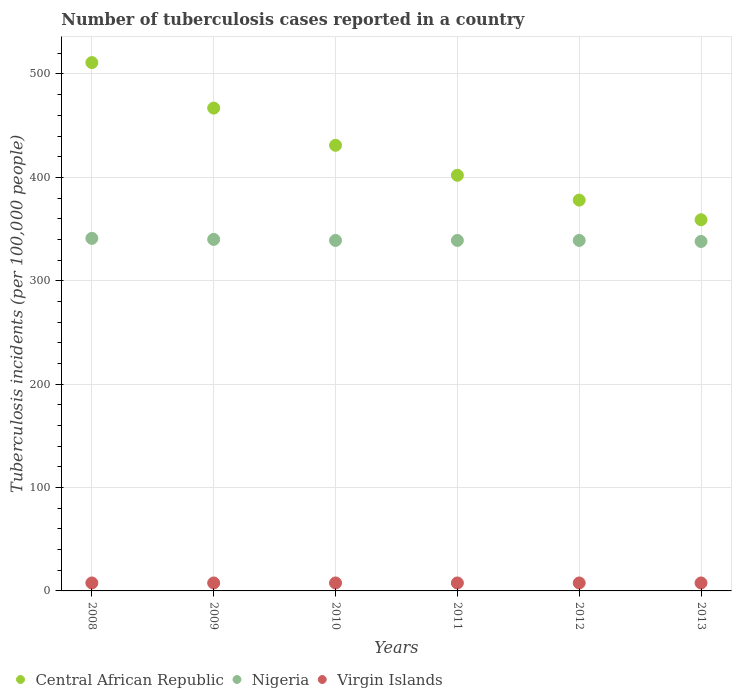Is the number of dotlines equal to the number of legend labels?
Keep it short and to the point. Yes. What is the number of tuberculosis cases reported in in Central African Republic in 2011?
Your response must be concise. 402. Across all years, what is the maximum number of tuberculosis cases reported in in Nigeria?
Your response must be concise. 341. Across all years, what is the minimum number of tuberculosis cases reported in in Nigeria?
Offer a terse response. 338. In which year was the number of tuberculosis cases reported in in Virgin Islands maximum?
Give a very brief answer. 2008. What is the total number of tuberculosis cases reported in in Nigeria in the graph?
Your answer should be compact. 2036. What is the difference between the number of tuberculosis cases reported in in Central African Republic in 2008 and that in 2010?
Ensure brevity in your answer.  80. What is the difference between the number of tuberculosis cases reported in in Virgin Islands in 2011 and the number of tuberculosis cases reported in in Nigeria in 2008?
Ensure brevity in your answer.  -333.3. What is the average number of tuberculosis cases reported in in Nigeria per year?
Keep it short and to the point. 339.33. In the year 2012, what is the difference between the number of tuberculosis cases reported in in Central African Republic and number of tuberculosis cases reported in in Virgin Islands?
Your answer should be compact. 370.3. In how many years, is the number of tuberculosis cases reported in in Central African Republic greater than 60?
Your answer should be compact. 6. What is the difference between the highest and the second highest number of tuberculosis cases reported in in Central African Republic?
Ensure brevity in your answer.  44. What is the difference between the highest and the lowest number of tuberculosis cases reported in in Central African Republic?
Keep it short and to the point. 152. In how many years, is the number of tuberculosis cases reported in in Virgin Islands greater than the average number of tuberculosis cases reported in in Virgin Islands taken over all years?
Provide a succinct answer. 0. Does the number of tuberculosis cases reported in in Central African Republic monotonically increase over the years?
Provide a short and direct response. No. Is the number of tuberculosis cases reported in in Nigeria strictly less than the number of tuberculosis cases reported in in Virgin Islands over the years?
Offer a very short reply. No. How many dotlines are there?
Offer a very short reply. 3. How many years are there in the graph?
Your answer should be very brief. 6. What is the difference between two consecutive major ticks on the Y-axis?
Your answer should be very brief. 100. Does the graph contain any zero values?
Provide a short and direct response. No. Does the graph contain grids?
Your answer should be very brief. Yes. What is the title of the graph?
Offer a terse response. Number of tuberculosis cases reported in a country. What is the label or title of the X-axis?
Your answer should be compact. Years. What is the label or title of the Y-axis?
Your answer should be compact. Tuberculosis incidents (per 100,0 people). What is the Tuberculosis incidents (per 100,000 people) in Central African Republic in 2008?
Give a very brief answer. 511. What is the Tuberculosis incidents (per 100,000 people) in Nigeria in 2008?
Your answer should be very brief. 341. What is the Tuberculosis incidents (per 100,000 people) in Virgin Islands in 2008?
Your answer should be compact. 7.7. What is the Tuberculosis incidents (per 100,000 people) in Central African Republic in 2009?
Your answer should be very brief. 467. What is the Tuberculosis incidents (per 100,000 people) of Nigeria in 2009?
Make the answer very short. 340. What is the Tuberculosis incidents (per 100,000 people) in Central African Republic in 2010?
Make the answer very short. 431. What is the Tuberculosis incidents (per 100,000 people) in Nigeria in 2010?
Your response must be concise. 339. What is the Tuberculosis incidents (per 100,000 people) in Central African Republic in 2011?
Provide a succinct answer. 402. What is the Tuberculosis incidents (per 100,000 people) in Nigeria in 2011?
Provide a short and direct response. 339. What is the Tuberculosis incidents (per 100,000 people) in Central African Republic in 2012?
Give a very brief answer. 378. What is the Tuberculosis incidents (per 100,000 people) in Nigeria in 2012?
Your response must be concise. 339. What is the Tuberculosis incidents (per 100,000 people) in Central African Republic in 2013?
Provide a succinct answer. 359. What is the Tuberculosis incidents (per 100,000 people) in Nigeria in 2013?
Make the answer very short. 338. Across all years, what is the maximum Tuberculosis incidents (per 100,000 people) in Central African Republic?
Ensure brevity in your answer.  511. Across all years, what is the maximum Tuberculosis incidents (per 100,000 people) in Nigeria?
Your answer should be very brief. 341. Across all years, what is the minimum Tuberculosis incidents (per 100,000 people) of Central African Republic?
Your answer should be compact. 359. Across all years, what is the minimum Tuberculosis incidents (per 100,000 people) in Nigeria?
Keep it short and to the point. 338. What is the total Tuberculosis incidents (per 100,000 people) of Central African Republic in the graph?
Provide a short and direct response. 2548. What is the total Tuberculosis incidents (per 100,000 people) in Nigeria in the graph?
Give a very brief answer. 2036. What is the total Tuberculosis incidents (per 100,000 people) of Virgin Islands in the graph?
Your response must be concise. 46.2. What is the difference between the Tuberculosis incidents (per 100,000 people) in Nigeria in 2008 and that in 2009?
Your answer should be very brief. 1. What is the difference between the Tuberculosis incidents (per 100,000 people) in Virgin Islands in 2008 and that in 2009?
Your response must be concise. 0. What is the difference between the Tuberculosis incidents (per 100,000 people) of Nigeria in 2008 and that in 2010?
Provide a succinct answer. 2. What is the difference between the Tuberculosis incidents (per 100,000 people) of Virgin Islands in 2008 and that in 2010?
Your answer should be very brief. 0. What is the difference between the Tuberculosis incidents (per 100,000 people) of Central African Republic in 2008 and that in 2011?
Ensure brevity in your answer.  109. What is the difference between the Tuberculosis incidents (per 100,000 people) in Virgin Islands in 2008 and that in 2011?
Your response must be concise. 0. What is the difference between the Tuberculosis incidents (per 100,000 people) of Central African Republic in 2008 and that in 2012?
Give a very brief answer. 133. What is the difference between the Tuberculosis incidents (per 100,000 people) in Nigeria in 2008 and that in 2012?
Offer a very short reply. 2. What is the difference between the Tuberculosis incidents (per 100,000 people) in Central African Republic in 2008 and that in 2013?
Offer a terse response. 152. What is the difference between the Tuberculosis incidents (per 100,000 people) of Virgin Islands in 2008 and that in 2013?
Your answer should be very brief. 0. What is the difference between the Tuberculosis incidents (per 100,000 people) of Central African Republic in 2009 and that in 2010?
Your response must be concise. 36. What is the difference between the Tuberculosis incidents (per 100,000 people) of Nigeria in 2009 and that in 2010?
Offer a terse response. 1. What is the difference between the Tuberculosis incidents (per 100,000 people) of Central African Republic in 2009 and that in 2012?
Your answer should be compact. 89. What is the difference between the Tuberculosis incidents (per 100,000 people) in Nigeria in 2009 and that in 2012?
Offer a very short reply. 1. What is the difference between the Tuberculosis incidents (per 100,000 people) in Virgin Islands in 2009 and that in 2012?
Provide a short and direct response. 0. What is the difference between the Tuberculosis incidents (per 100,000 people) of Central African Republic in 2009 and that in 2013?
Offer a very short reply. 108. What is the difference between the Tuberculosis incidents (per 100,000 people) in Nigeria in 2009 and that in 2013?
Give a very brief answer. 2. What is the difference between the Tuberculosis incidents (per 100,000 people) of Virgin Islands in 2010 and that in 2012?
Provide a short and direct response. 0. What is the difference between the Tuberculosis incidents (per 100,000 people) of Nigeria in 2010 and that in 2013?
Offer a terse response. 1. What is the difference between the Tuberculosis incidents (per 100,000 people) of Virgin Islands in 2010 and that in 2013?
Your answer should be very brief. 0. What is the difference between the Tuberculosis incidents (per 100,000 people) of Central African Republic in 2011 and that in 2012?
Your answer should be very brief. 24. What is the difference between the Tuberculosis incidents (per 100,000 people) in Virgin Islands in 2011 and that in 2012?
Provide a short and direct response. 0. What is the difference between the Tuberculosis incidents (per 100,000 people) in Central African Republic in 2011 and that in 2013?
Offer a terse response. 43. What is the difference between the Tuberculosis incidents (per 100,000 people) in Nigeria in 2011 and that in 2013?
Make the answer very short. 1. What is the difference between the Tuberculosis incidents (per 100,000 people) in Central African Republic in 2012 and that in 2013?
Keep it short and to the point. 19. What is the difference between the Tuberculosis incidents (per 100,000 people) of Central African Republic in 2008 and the Tuberculosis incidents (per 100,000 people) of Nigeria in 2009?
Keep it short and to the point. 171. What is the difference between the Tuberculosis incidents (per 100,000 people) in Central African Republic in 2008 and the Tuberculosis incidents (per 100,000 people) in Virgin Islands in 2009?
Offer a very short reply. 503.3. What is the difference between the Tuberculosis incidents (per 100,000 people) in Nigeria in 2008 and the Tuberculosis incidents (per 100,000 people) in Virgin Islands in 2009?
Provide a short and direct response. 333.3. What is the difference between the Tuberculosis incidents (per 100,000 people) in Central African Republic in 2008 and the Tuberculosis incidents (per 100,000 people) in Nigeria in 2010?
Provide a short and direct response. 172. What is the difference between the Tuberculosis incidents (per 100,000 people) in Central African Republic in 2008 and the Tuberculosis incidents (per 100,000 people) in Virgin Islands in 2010?
Offer a very short reply. 503.3. What is the difference between the Tuberculosis incidents (per 100,000 people) in Nigeria in 2008 and the Tuberculosis incidents (per 100,000 people) in Virgin Islands in 2010?
Provide a succinct answer. 333.3. What is the difference between the Tuberculosis incidents (per 100,000 people) of Central African Republic in 2008 and the Tuberculosis incidents (per 100,000 people) of Nigeria in 2011?
Give a very brief answer. 172. What is the difference between the Tuberculosis incidents (per 100,000 people) of Central African Republic in 2008 and the Tuberculosis incidents (per 100,000 people) of Virgin Islands in 2011?
Make the answer very short. 503.3. What is the difference between the Tuberculosis incidents (per 100,000 people) in Nigeria in 2008 and the Tuberculosis incidents (per 100,000 people) in Virgin Islands in 2011?
Your response must be concise. 333.3. What is the difference between the Tuberculosis incidents (per 100,000 people) in Central African Republic in 2008 and the Tuberculosis incidents (per 100,000 people) in Nigeria in 2012?
Your response must be concise. 172. What is the difference between the Tuberculosis incidents (per 100,000 people) of Central African Republic in 2008 and the Tuberculosis incidents (per 100,000 people) of Virgin Islands in 2012?
Give a very brief answer. 503.3. What is the difference between the Tuberculosis incidents (per 100,000 people) in Nigeria in 2008 and the Tuberculosis incidents (per 100,000 people) in Virgin Islands in 2012?
Provide a short and direct response. 333.3. What is the difference between the Tuberculosis incidents (per 100,000 people) of Central African Republic in 2008 and the Tuberculosis incidents (per 100,000 people) of Nigeria in 2013?
Provide a succinct answer. 173. What is the difference between the Tuberculosis incidents (per 100,000 people) of Central African Republic in 2008 and the Tuberculosis incidents (per 100,000 people) of Virgin Islands in 2013?
Your answer should be compact. 503.3. What is the difference between the Tuberculosis incidents (per 100,000 people) of Nigeria in 2008 and the Tuberculosis incidents (per 100,000 people) of Virgin Islands in 2013?
Make the answer very short. 333.3. What is the difference between the Tuberculosis incidents (per 100,000 people) in Central African Republic in 2009 and the Tuberculosis incidents (per 100,000 people) in Nigeria in 2010?
Your answer should be very brief. 128. What is the difference between the Tuberculosis incidents (per 100,000 people) of Central African Republic in 2009 and the Tuberculosis incidents (per 100,000 people) of Virgin Islands in 2010?
Ensure brevity in your answer.  459.3. What is the difference between the Tuberculosis incidents (per 100,000 people) of Nigeria in 2009 and the Tuberculosis incidents (per 100,000 people) of Virgin Islands in 2010?
Your answer should be very brief. 332.3. What is the difference between the Tuberculosis incidents (per 100,000 people) of Central African Republic in 2009 and the Tuberculosis incidents (per 100,000 people) of Nigeria in 2011?
Your answer should be very brief. 128. What is the difference between the Tuberculosis incidents (per 100,000 people) in Central African Republic in 2009 and the Tuberculosis incidents (per 100,000 people) in Virgin Islands in 2011?
Offer a terse response. 459.3. What is the difference between the Tuberculosis incidents (per 100,000 people) of Nigeria in 2009 and the Tuberculosis incidents (per 100,000 people) of Virgin Islands in 2011?
Provide a succinct answer. 332.3. What is the difference between the Tuberculosis incidents (per 100,000 people) in Central African Republic in 2009 and the Tuberculosis incidents (per 100,000 people) in Nigeria in 2012?
Ensure brevity in your answer.  128. What is the difference between the Tuberculosis incidents (per 100,000 people) of Central African Republic in 2009 and the Tuberculosis incidents (per 100,000 people) of Virgin Islands in 2012?
Provide a succinct answer. 459.3. What is the difference between the Tuberculosis incidents (per 100,000 people) in Nigeria in 2009 and the Tuberculosis incidents (per 100,000 people) in Virgin Islands in 2012?
Offer a terse response. 332.3. What is the difference between the Tuberculosis incidents (per 100,000 people) in Central African Republic in 2009 and the Tuberculosis incidents (per 100,000 people) in Nigeria in 2013?
Give a very brief answer. 129. What is the difference between the Tuberculosis incidents (per 100,000 people) of Central African Republic in 2009 and the Tuberculosis incidents (per 100,000 people) of Virgin Islands in 2013?
Keep it short and to the point. 459.3. What is the difference between the Tuberculosis incidents (per 100,000 people) in Nigeria in 2009 and the Tuberculosis incidents (per 100,000 people) in Virgin Islands in 2013?
Ensure brevity in your answer.  332.3. What is the difference between the Tuberculosis incidents (per 100,000 people) of Central African Republic in 2010 and the Tuberculosis incidents (per 100,000 people) of Nigeria in 2011?
Offer a terse response. 92. What is the difference between the Tuberculosis incidents (per 100,000 people) in Central African Republic in 2010 and the Tuberculosis incidents (per 100,000 people) in Virgin Islands in 2011?
Offer a terse response. 423.3. What is the difference between the Tuberculosis incidents (per 100,000 people) of Nigeria in 2010 and the Tuberculosis incidents (per 100,000 people) of Virgin Islands in 2011?
Your answer should be compact. 331.3. What is the difference between the Tuberculosis incidents (per 100,000 people) of Central African Republic in 2010 and the Tuberculosis incidents (per 100,000 people) of Nigeria in 2012?
Ensure brevity in your answer.  92. What is the difference between the Tuberculosis incidents (per 100,000 people) in Central African Republic in 2010 and the Tuberculosis incidents (per 100,000 people) in Virgin Islands in 2012?
Your response must be concise. 423.3. What is the difference between the Tuberculosis incidents (per 100,000 people) in Nigeria in 2010 and the Tuberculosis incidents (per 100,000 people) in Virgin Islands in 2012?
Your response must be concise. 331.3. What is the difference between the Tuberculosis incidents (per 100,000 people) in Central African Republic in 2010 and the Tuberculosis incidents (per 100,000 people) in Nigeria in 2013?
Provide a succinct answer. 93. What is the difference between the Tuberculosis incidents (per 100,000 people) in Central African Republic in 2010 and the Tuberculosis incidents (per 100,000 people) in Virgin Islands in 2013?
Your answer should be compact. 423.3. What is the difference between the Tuberculosis incidents (per 100,000 people) of Nigeria in 2010 and the Tuberculosis incidents (per 100,000 people) of Virgin Islands in 2013?
Your response must be concise. 331.3. What is the difference between the Tuberculosis incidents (per 100,000 people) in Central African Republic in 2011 and the Tuberculosis incidents (per 100,000 people) in Virgin Islands in 2012?
Give a very brief answer. 394.3. What is the difference between the Tuberculosis incidents (per 100,000 people) in Nigeria in 2011 and the Tuberculosis incidents (per 100,000 people) in Virgin Islands in 2012?
Provide a succinct answer. 331.3. What is the difference between the Tuberculosis incidents (per 100,000 people) in Central African Republic in 2011 and the Tuberculosis incidents (per 100,000 people) in Nigeria in 2013?
Offer a very short reply. 64. What is the difference between the Tuberculosis incidents (per 100,000 people) of Central African Republic in 2011 and the Tuberculosis incidents (per 100,000 people) of Virgin Islands in 2013?
Keep it short and to the point. 394.3. What is the difference between the Tuberculosis incidents (per 100,000 people) in Nigeria in 2011 and the Tuberculosis incidents (per 100,000 people) in Virgin Islands in 2013?
Ensure brevity in your answer.  331.3. What is the difference between the Tuberculosis incidents (per 100,000 people) in Central African Republic in 2012 and the Tuberculosis incidents (per 100,000 people) in Virgin Islands in 2013?
Make the answer very short. 370.3. What is the difference between the Tuberculosis incidents (per 100,000 people) of Nigeria in 2012 and the Tuberculosis incidents (per 100,000 people) of Virgin Islands in 2013?
Your answer should be very brief. 331.3. What is the average Tuberculosis incidents (per 100,000 people) in Central African Republic per year?
Offer a terse response. 424.67. What is the average Tuberculosis incidents (per 100,000 people) in Nigeria per year?
Make the answer very short. 339.33. What is the average Tuberculosis incidents (per 100,000 people) in Virgin Islands per year?
Your answer should be compact. 7.7. In the year 2008, what is the difference between the Tuberculosis incidents (per 100,000 people) of Central African Republic and Tuberculosis incidents (per 100,000 people) of Nigeria?
Offer a very short reply. 170. In the year 2008, what is the difference between the Tuberculosis incidents (per 100,000 people) of Central African Republic and Tuberculosis incidents (per 100,000 people) of Virgin Islands?
Provide a succinct answer. 503.3. In the year 2008, what is the difference between the Tuberculosis incidents (per 100,000 people) in Nigeria and Tuberculosis incidents (per 100,000 people) in Virgin Islands?
Your response must be concise. 333.3. In the year 2009, what is the difference between the Tuberculosis incidents (per 100,000 people) in Central African Republic and Tuberculosis incidents (per 100,000 people) in Nigeria?
Give a very brief answer. 127. In the year 2009, what is the difference between the Tuberculosis incidents (per 100,000 people) in Central African Republic and Tuberculosis incidents (per 100,000 people) in Virgin Islands?
Provide a succinct answer. 459.3. In the year 2009, what is the difference between the Tuberculosis incidents (per 100,000 people) in Nigeria and Tuberculosis incidents (per 100,000 people) in Virgin Islands?
Provide a short and direct response. 332.3. In the year 2010, what is the difference between the Tuberculosis incidents (per 100,000 people) of Central African Republic and Tuberculosis incidents (per 100,000 people) of Nigeria?
Make the answer very short. 92. In the year 2010, what is the difference between the Tuberculosis incidents (per 100,000 people) of Central African Republic and Tuberculosis incidents (per 100,000 people) of Virgin Islands?
Offer a very short reply. 423.3. In the year 2010, what is the difference between the Tuberculosis incidents (per 100,000 people) of Nigeria and Tuberculosis incidents (per 100,000 people) of Virgin Islands?
Provide a short and direct response. 331.3. In the year 2011, what is the difference between the Tuberculosis incidents (per 100,000 people) of Central African Republic and Tuberculosis incidents (per 100,000 people) of Nigeria?
Your response must be concise. 63. In the year 2011, what is the difference between the Tuberculosis incidents (per 100,000 people) of Central African Republic and Tuberculosis incidents (per 100,000 people) of Virgin Islands?
Ensure brevity in your answer.  394.3. In the year 2011, what is the difference between the Tuberculosis incidents (per 100,000 people) in Nigeria and Tuberculosis incidents (per 100,000 people) in Virgin Islands?
Give a very brief answer. 331.3. In the year 2012, what is the difference between the Tuberculosis incidents (per 100,000 people) of Central African Republic and Tuberculosis incidents (per 100,000 people) of Nigeria?
Your response must be concise. 39. In the year 2012, what is the difference between the Tuberculosis incidents (per 100,000 people) of Central African Republic and Tuberculosis incidents (per 100,000 people) of Virgin Islands?
Your answer should be compact. 370.3. In the year 2012, what is the difference between the Tuberculosis incidents (per 100,000 people) in Nigeria and Tuberculosis incidents (per 100,000 people) in Virgin Islands?
Ensure brevity in your answer.  331.3. In the year 2013, what is the difference between the Tuberculosis incidents (per 100,000 people) of Central African Republic and Tuberculosis incidents (per 100,000 people) of Nigeria?
Make the answer very short. 21. In the year 2013, what is the difference between the Tuberculosis incidents (per 100,000 people) of Central African Republic and Tuberculosis incidents (per 100,000 people) of Virgin Islands?
Ensure brevity in your answer.  351.3. In the year 2013, what is the difference between the Tuberculosis incidents (per 100,000 people) in Nigeria and Tuberculosis incidents (per 100,000 people) in Virgin Islands?
Make the answer very short. 330.3. What is the ratio of the Tuberculosis incidents (per 100,000 people) of Central African Republic in 2008 to that in 2009?
Give a very brief answer. 1.09. What is the ratio of the Tuberculosis incidents (per 100,000 people) in Nigeria in 2008 to that in 2009?
Provide a succinct answer. 1. What is the ratio of the Tuberculosis incidents (per 100,000 people) of Virgin Islands in 2008 to that in 2009?
Keep it short and to the point. 1. What is the ratio of the Tuberculosis incidents (per 100,000 people) in Central African Republic in 2008 to that in 2010?
Your answer should be compact. 1.19. What is the ratio of the Tuberculosis incidents (per 100,000 people) of Nigeria in 2008 to that in 2010?
Provide a short and direct response. 1.01. What is the ratio of the Tuberculosis incidents (per 100,000 people) in Central African Republic in 2008 to that in 2011?
Ensure brevity in your answer.  1.27. What is the ratio of the Tuberculosis incidents (per 100,000 people) of Nigeria in 2008 to that in 2011?
Your response must be concise. 1.01. What is the ratio of the Tuberculosis incidents (per 100,000 people) in Central African Republic in 2008 to that in 2012?
Your answer should be compact. 1.35. What is the ratio of the Tuberculosis incidents (per 100,000 people) of Nigeria in 2008 to that in 2012?
Offer a very short reply. 1.01. What is the ratio of the Tuberculosis incidents (per 100,000 people) of Central African Republic in 2008 to that in 2013?
Ensure brevity in your answer.  1.42. What is the ratio of the Tuberculosis incidents (per 100,000 people) in Nigeria in 2008 to that in 2013?
Ensure brevity in your answer.  1.01. What is the ratio of the Tuberculosis incidents (per 100,000 people) in Virgin Islands in 2008 to that in 2013?
Keep it short and to the point. 1. What is the ratio of the Tuberculosis incidents (per 100,000 people) in Central African Republic in 2009 to that in 2010?
Your answer should be compact. 1.08. What is the ratio of the Tuberculosis incidents (per 100,000 people) in Nigeria in 2009 to that in 2010?
Ensure brevity in your answer.  1. What is the ratio of the Tuberculosis incidents (per 100,000 people) in Virgin Islands in 2009 to that in 2010?
Offer a very short reply. 1. What is the ratio of the Tuberculosis incidents (per 100,000 people) in Central African Republic in 2009 to that in 2011?
Keep it short and to the point. 1.16. What is the ratio of the Tuberculosis incidents (per 100,000 people) of Nigeria in 2009 to that in 2011?
Make the answer very short. 1. What is the ratio of the Tuberculosis incidents (per 100,000 people) of Virgin Islands in 2009 to that in 2011?
Provide a short and direct response. 1. What is the ratio of the Tuberculosis incidents (per 100,000 people) in Central African Republic in 2009 to that in 2012?
Offer a very short reply. 1.24. What is the ratio of the Tuberculosis incidents (per 100,000 people) of Virgin Islands in 2009 to that in 2012?
Your response must be concise. 1. What is the ratio of the Tuberculosis incidents (per 100,000 people) in Central African Republic in 2009 to that in 2013?
Offer a very short reply. 1.3. What is the ratio of the Tuberculosis incidents (per 100,000 people) in Nigeria in 2009 to that in 2013?
Your answer should be compact. 1.01. What is the ratio of the Tuberculosis incidents (per 100,000 people) of Central African Republic in 2010 to that in 2011?
Your answer should be very brief. 1.07. What is the ratio of the Tuberculosis incidents (per 100,000 people) of Central African Republic in 2010 to that in 2012?
Provide a succinct answer. 1.14. What is the ratio of the Tuberculosis incidents (per 100,000 people) of Nigeria in 2010 to that in 2012?
Keep it short and to the point. 1. What is the ratio of the Tuberculosis incidents (per 100,000 people) in Virgin Islands in 2010 to that in 2012?
Your answer should be compact. 1. What is the ratio of the Tuberculosis incidents (per 100,000 people) in Central African Republic in 2010 to that in 2013?
Your answer should be compact. 1.2. What is the ratio of the Tuberculosis incidents (per 100,000 people) in Central African Republic in 2011 to that in 2012?
Make the answer very short. 1.06. What is the ratio of the Tuberculosis incidents (per 100,000 people) of Virgin Islands in 2011 to that in 2012?
Give a very brief answer. 1. What is the ratio of the Tuberculosis incidents (per 100,000 people) in Central African Republic in 2011 to that in 2013?
Your answer should be very brief. 1.12. What is the ratio of the Tuberculosis incidents (per 100,000 people) of Nigeria in 2011 to that in 2013?
Provide a succinct answer. 1. What is the ratio of the Tuberculosis incidents (per 100,000 people) of Virgin Islands in 2011 to that in 2013?
Ensure brevity in your answer.  1. What is the ratio of the Tuberculosis incidents (per 100,000 people) of Central African Republic in 2012 to that in 2013?
Ensure brevity in your answer.  1.05. What is the ratio of the Tuberculosis incidents (per 100,000 people) in Nigeria in 2012 to that in 2013?
Provide a short and direct response. 1. What is the difference between the highest and the second highest Tuberculosis incidents (per 100,000 people) in Central African Republic?
Provide a succinct answer. 44. What is the difference between the highest and the second highest Tuberculosis incidents (per 100,000 people) in Nigeria?
Give a very brief answer. 1. What is the difference between the highest and the lowest Tuberculosis incidents (per 100,000 people) in Central African Republic?
Your answer should be compact. 152. What is the difference between the highest and the lowest Tuberculosis incidents (per 100,000 people) in Nigeria?
Your response must be concise. 3. 